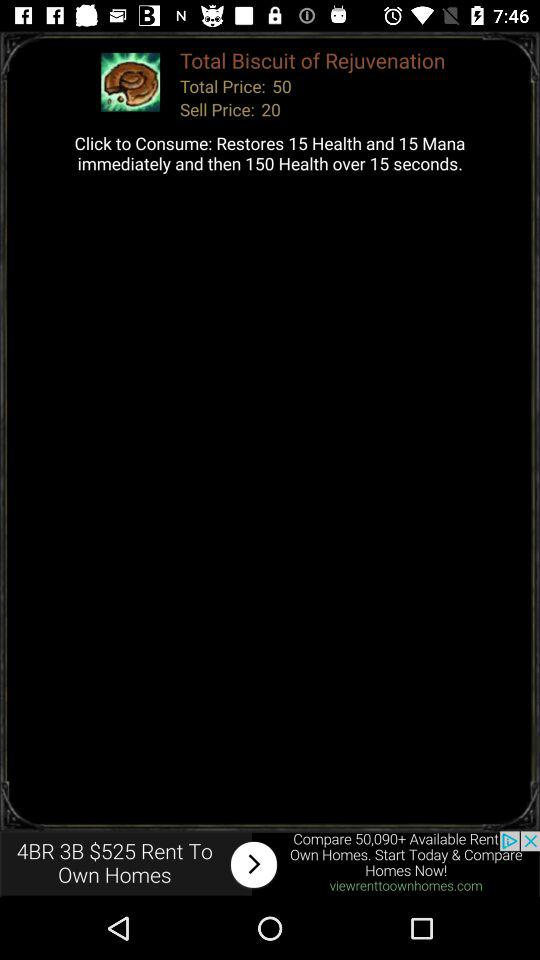What is the selling price? The selling price is 20. 